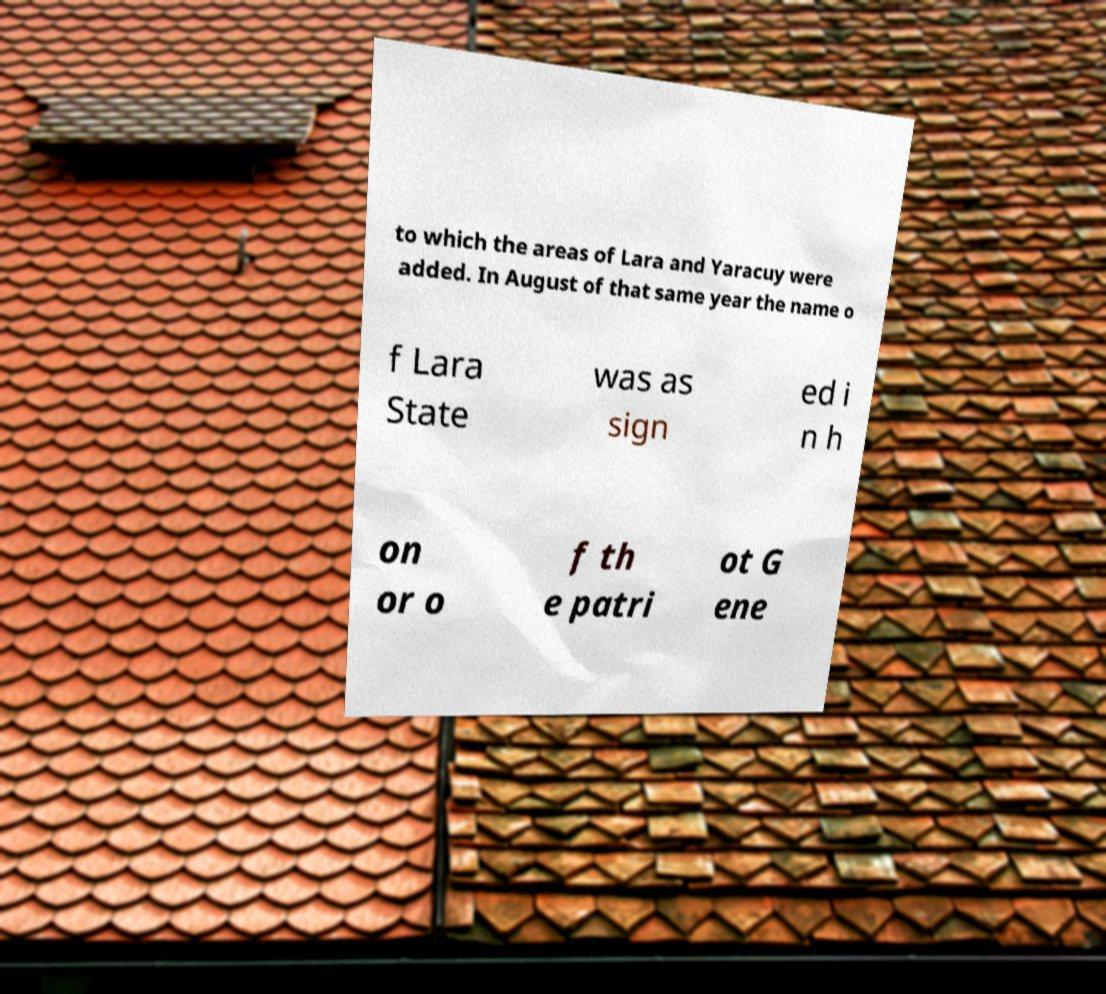There's text embedded in this image that I need extracted. Can you transcribe it verbatim? to which the areas of Lara and Yaracuy were added. In August of that same year the name o f Lara State was as sign ed i n h on or o f th e patri ot G ene 